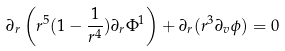Convert formula to latex. <formula><loc_0><loc_0><loc_500><loc_500>\partial _ { r } \left ( r ^ { 5 } ( 1 - \frac { 1 } { r ^ { 4 } } ) \partial _ { r } \Phi ^ { 1 } \right ) + \partial _ { r } ( r ^ { 3 } \partial _ { v } \phi ) = 0</formula> 